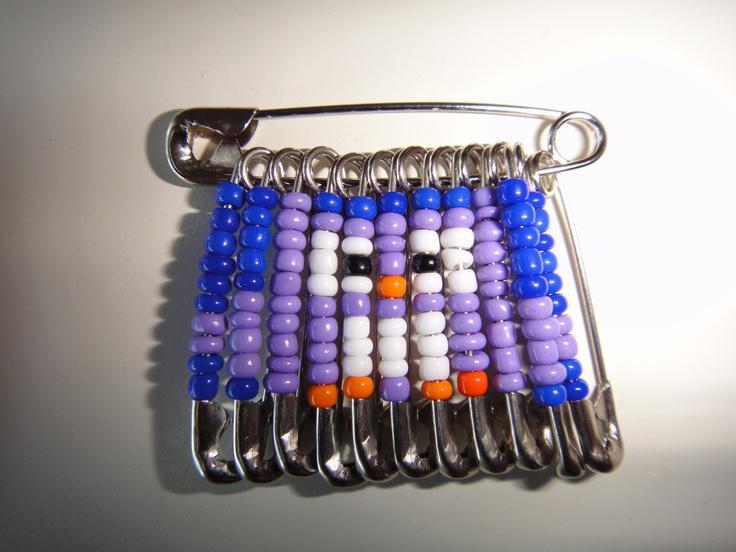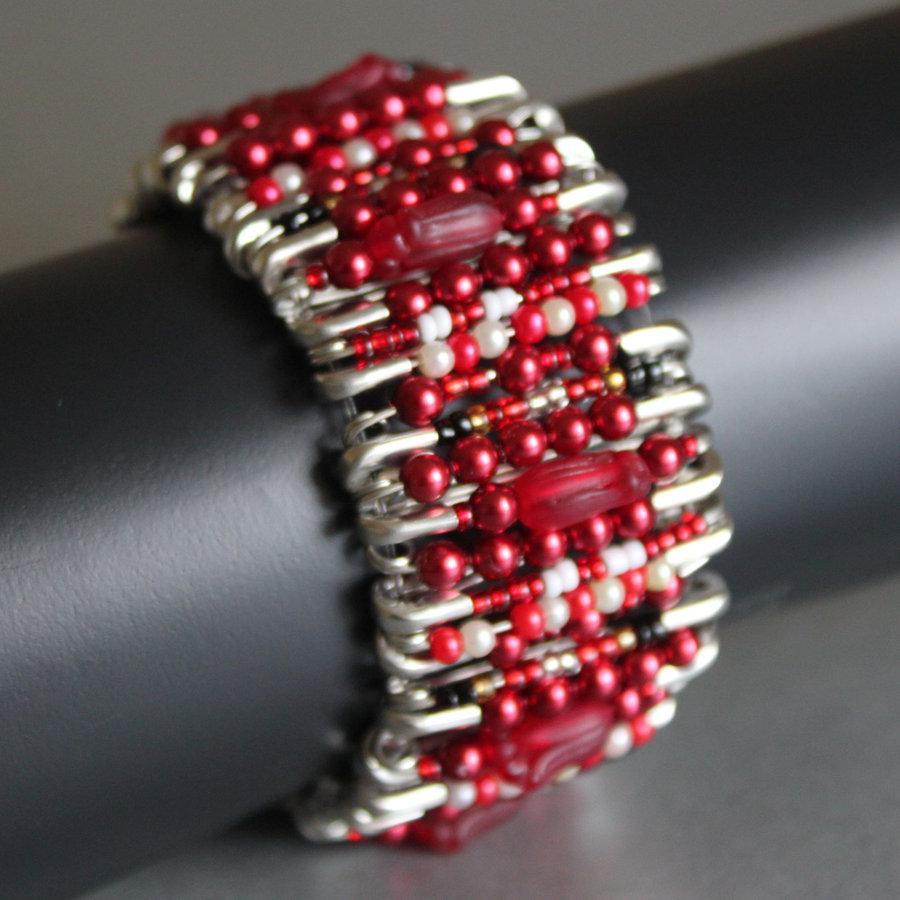The first image is the image on the left, the second image is the image on the right. Given the left and right images, does the statement "the beads hanging from the safety pin to the left are mostly purple and blue" hold true? Answer yes or no. Yes. The first image is the image on the left, the second image is the image on the right. Analyze the images presented: Is the assertion "One image shows a safety pin bracelet displayed on a flat surface, and the other image shows a safety pin strung with colored beads that form an animal image." valid? Answer yes or no. No. 